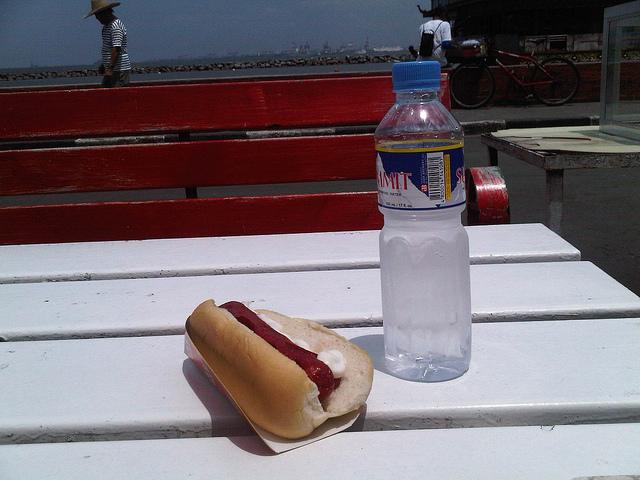Is the food eaten?
Keep it brief. No. Is there mustard on the hot dog?
Quick response, please. No. Where will the meal be eaten?
Give a very brief answer. Outside. 